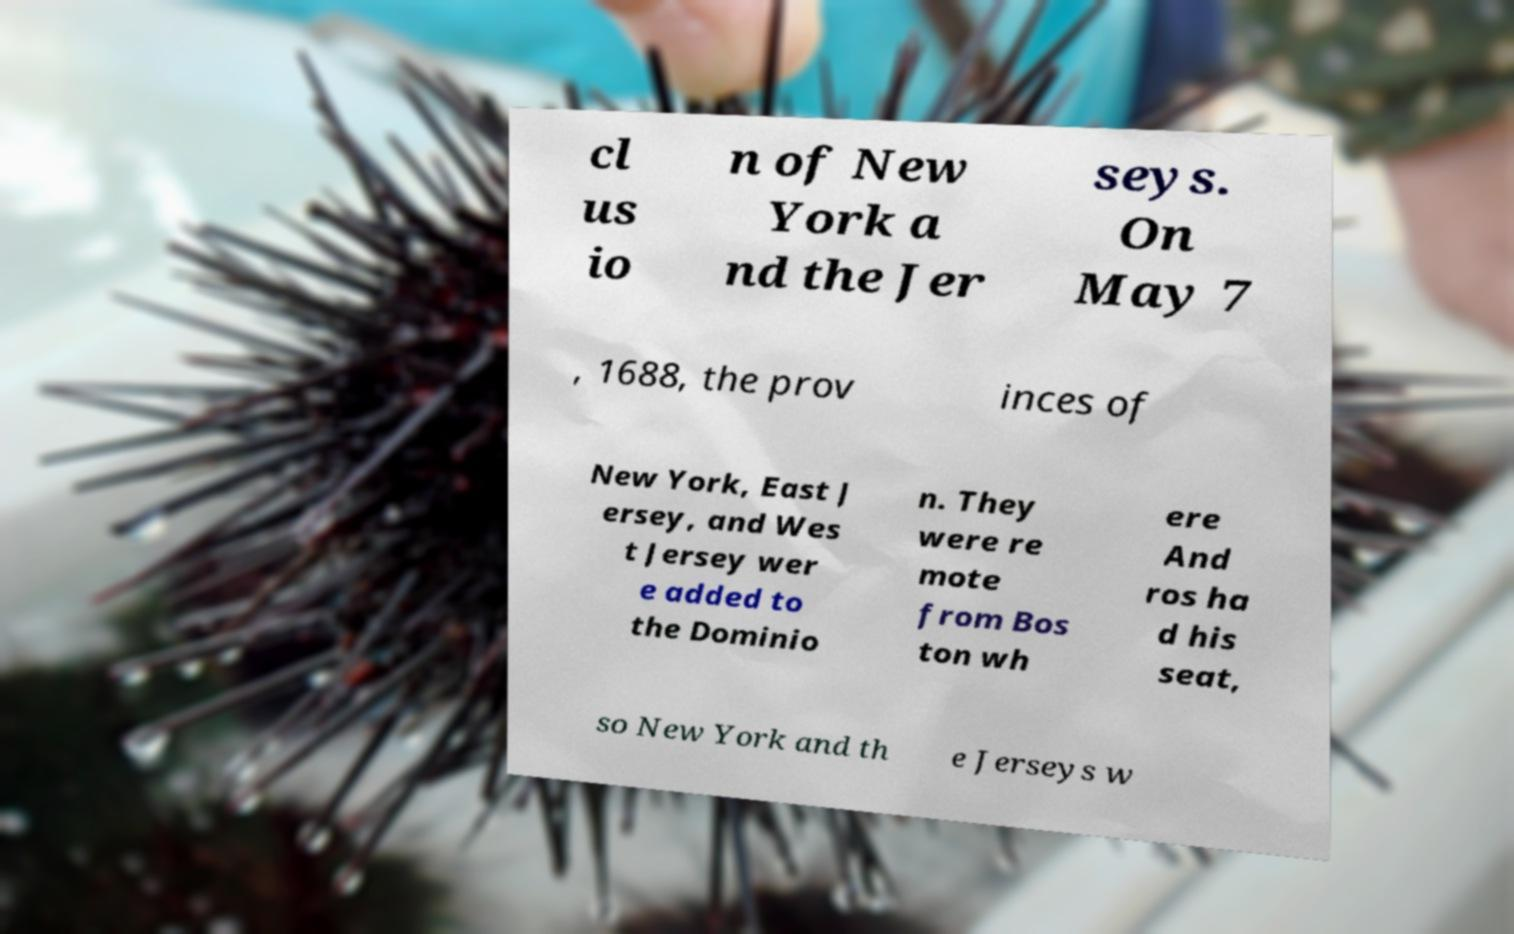Please identify and transcribe the text found in this image. cl us io n of New York a nd the Jer seys. On May 7 , 1688, the prov inces of New York, East J ersey, and Wes t Jersey wer e added to the Dominio n. They were re mote from Bos ton wh ere And ros ha d his seat, so New York and th e Jerseys w 